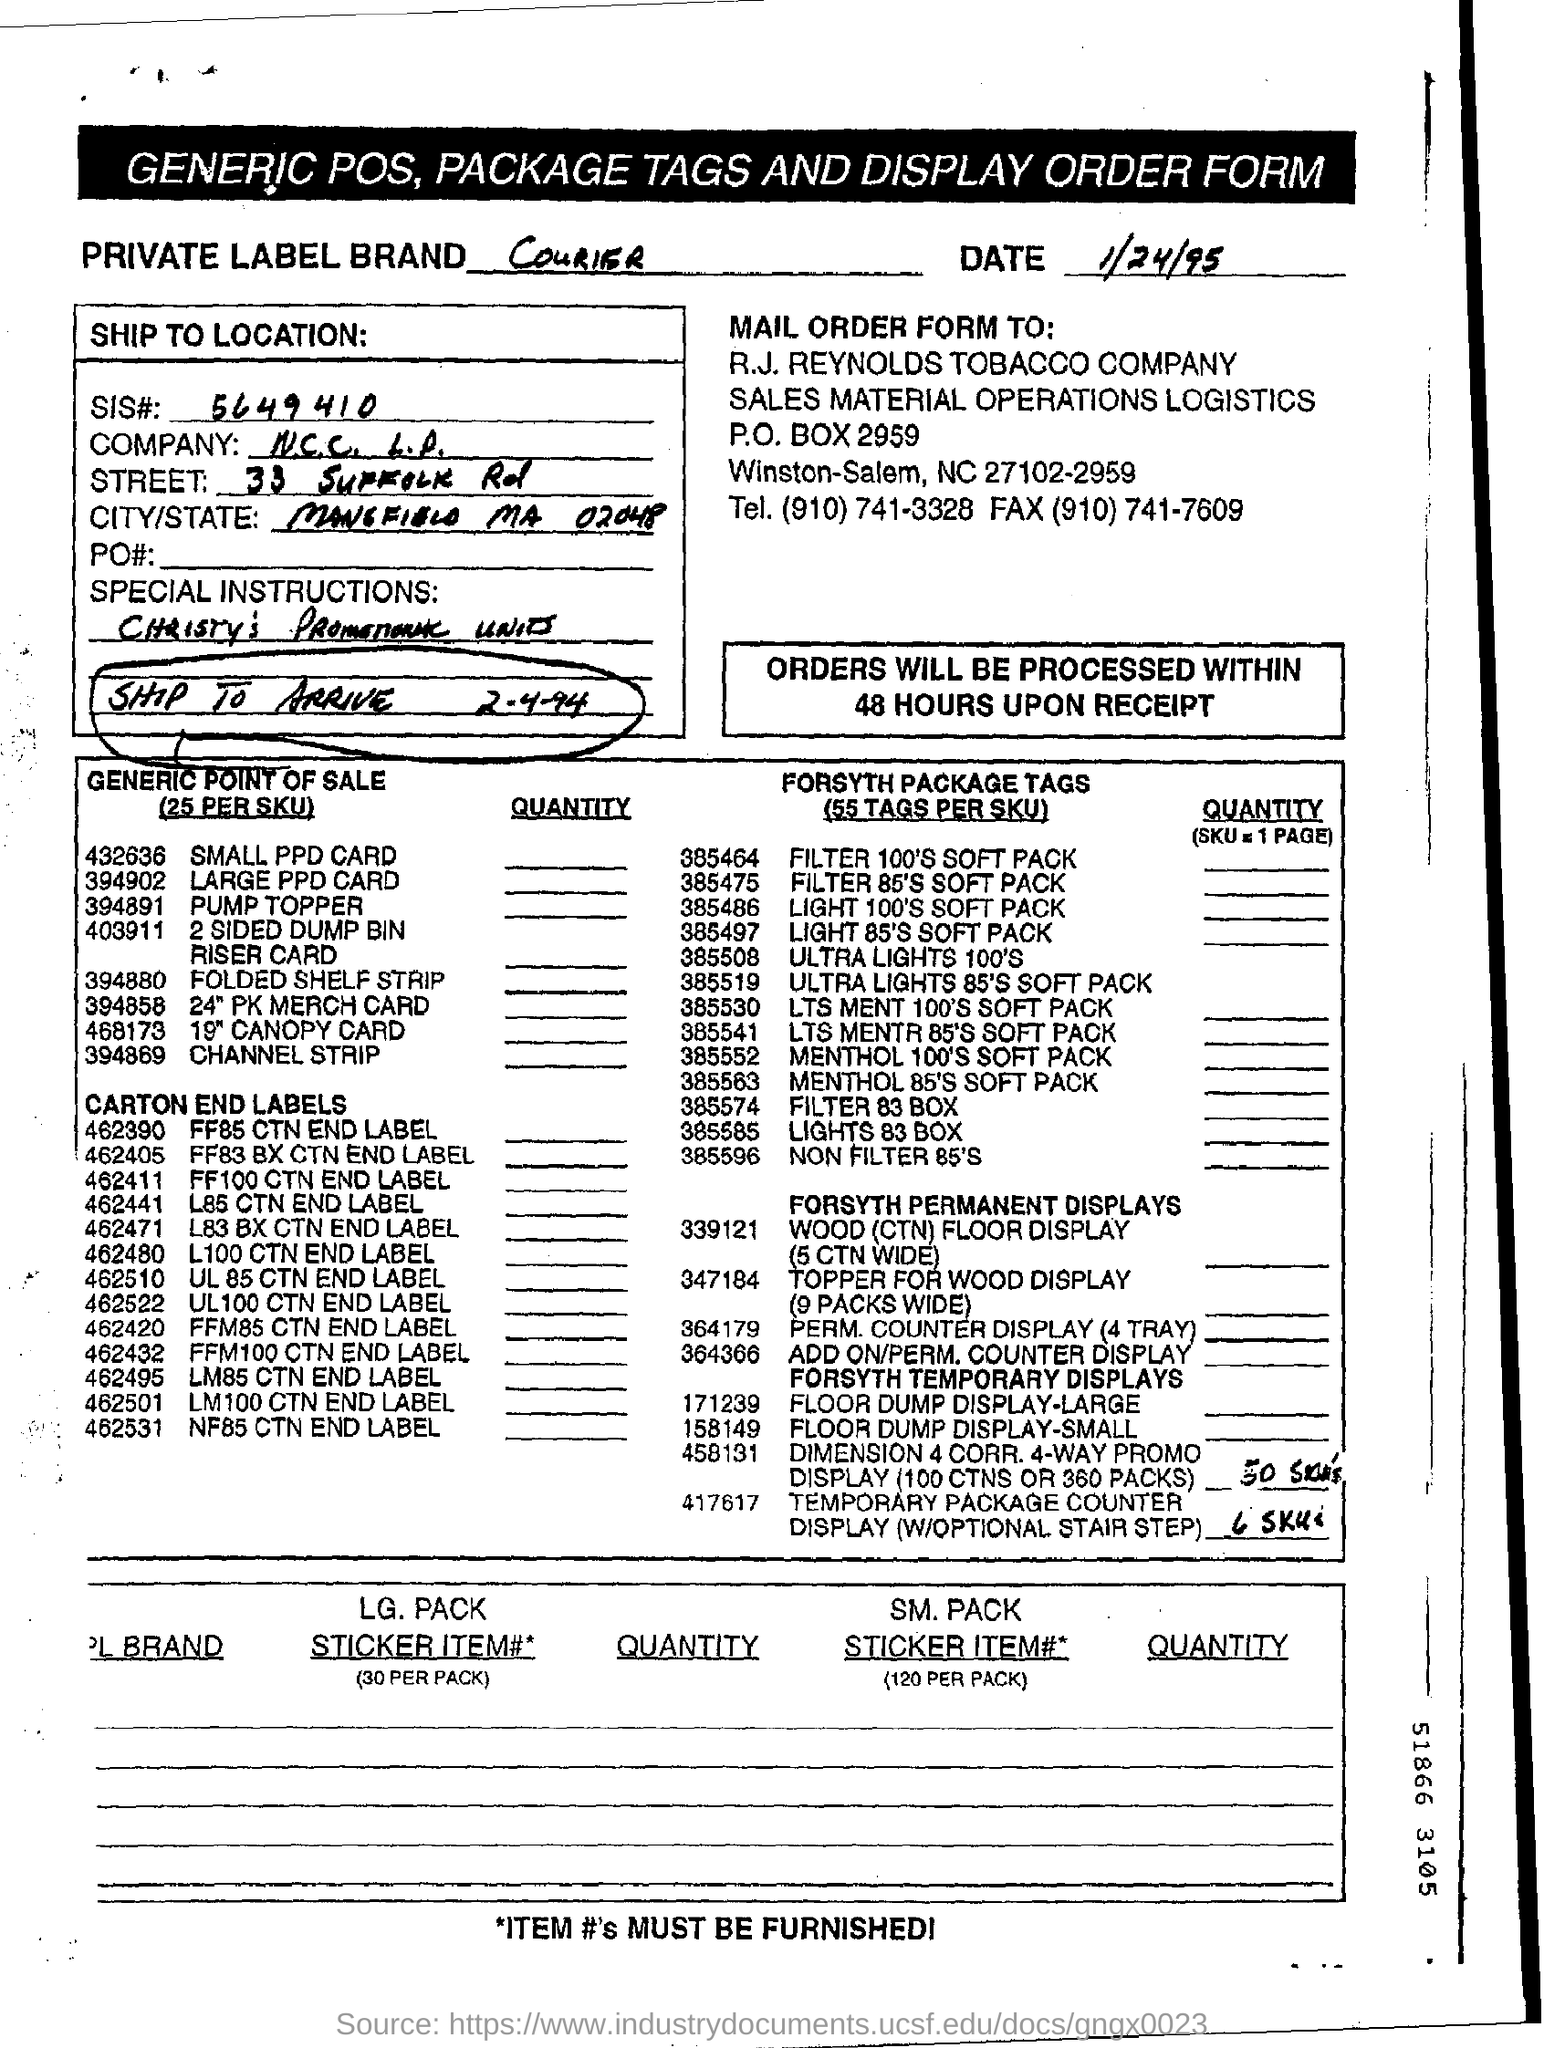What form is this?
Your answer should be compact. GENERIC POS, PACKAGE TAGS AND DISPLAY ORDER FORM. When is the form dated?
Make the answer very short. 1/24/95. What is the SIS #?
Offer a very short reply. 5649410. Within how many hours upon receipt will the orders be processed?
Offer a terse response. 48 hours. 